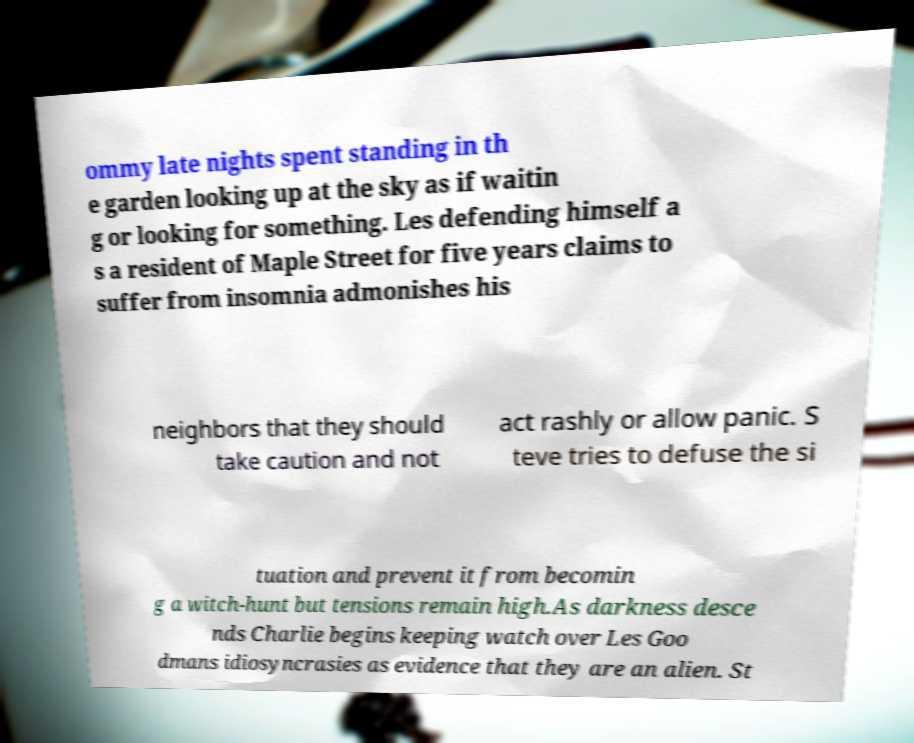Please read and relay the text visible in this image. What does it say? ommy late nights spent standing in th e garden looking up at the sky as if waitin g or looking for something. Les defending himself a s a resident of Maple Street for five years claims to suffer from insomnia admonishes his neighbors that they should take caution and not act rashly or allow panic. S teve tries to defuse the si tuation and prevent it from becomin g a witch-hunt but tensions remain high.As darkness desce nds Charlie begins keeping watch over Les Goo dmans idiosyncrasies as evidence that they are an alien. St 